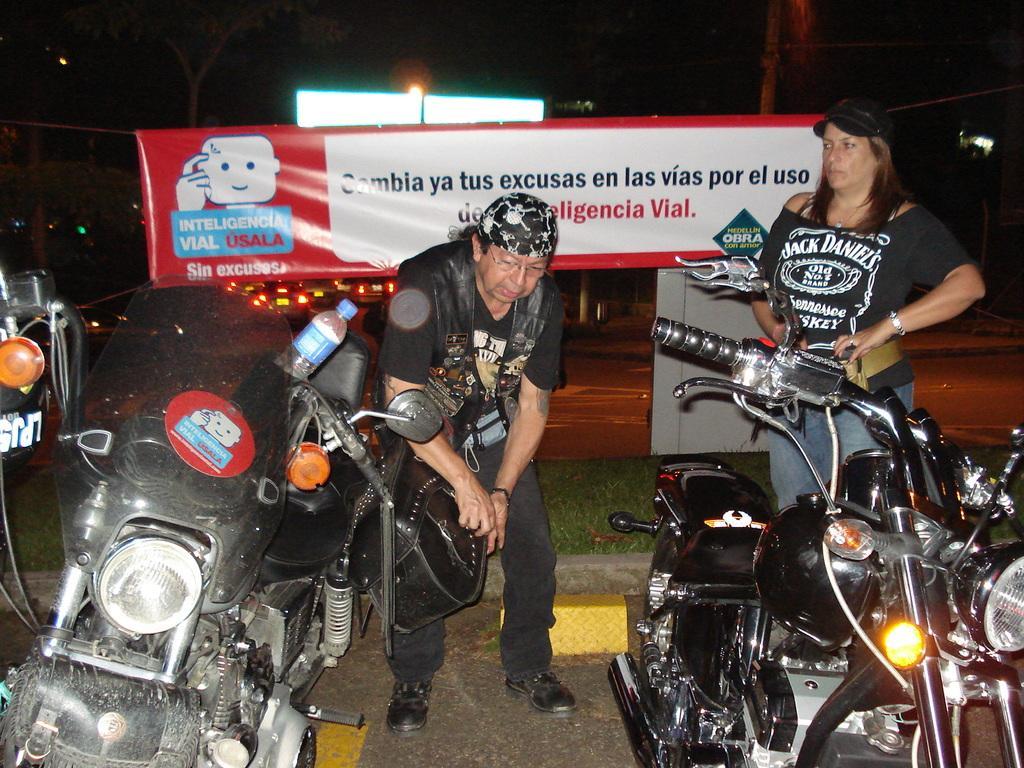Could you give a brief overview of what you see in this image? In this image we can see two women standing on the road. We can also see some motorbikes parked aside, a bottle in a bike and some grass. On the backside we can see a banner with the picture and some text on it, some lights, vehicles on the road and a pole. 